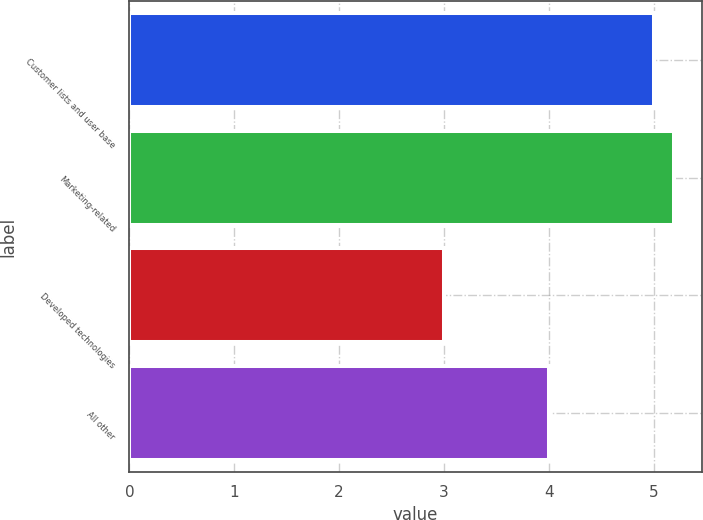Convert chart to OTSL. <chart><loc_0><loc_0><loc_500><loc_500><bar_chart><fcel>Customer lists and user base<fcel>Marketing-related<fcel>Developed technologies<fcel>All other<nl><fcel>5<fcel>5.2<fcel>3<fcel>4<nl></chart> 